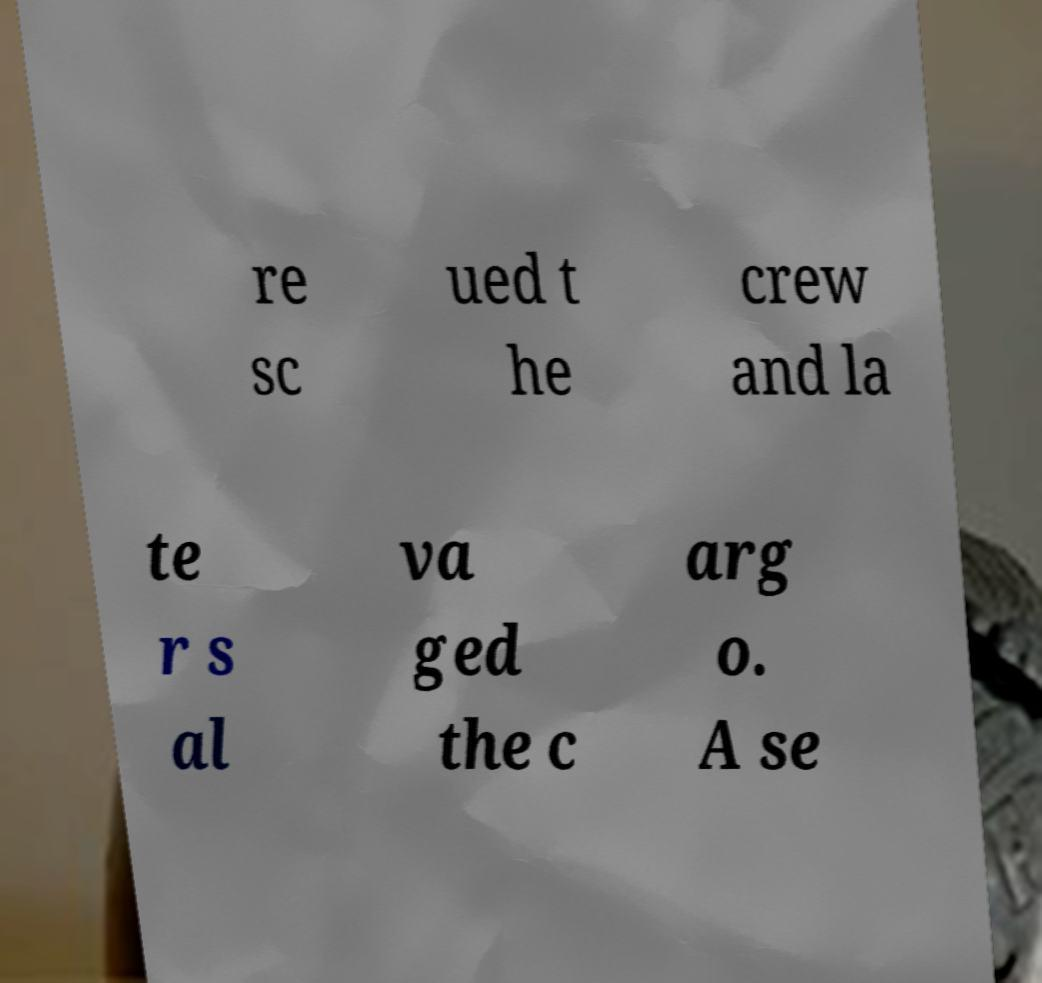Can you accurately transcribe the text from the provided image for me? re sc ued t he crew and la te r s al va ged the c arg o. A se 